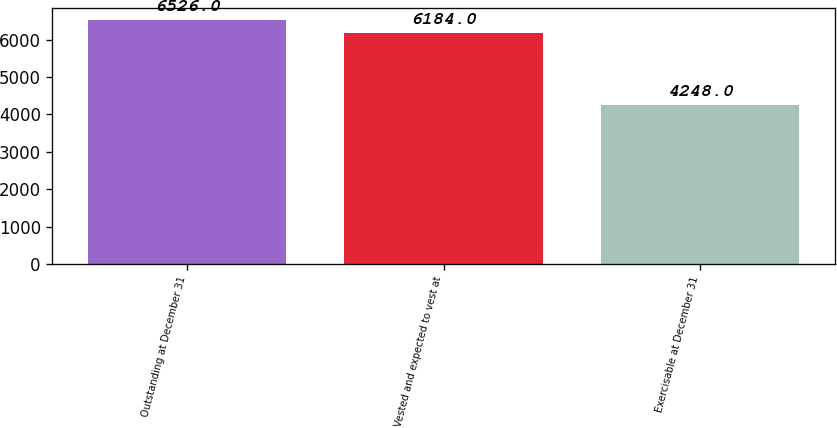Convert chart to OTSL. <chart><loc_0><loc_0><loc_500><loc_500><bar_chart><fcel>Outstanding at December 31<fcel>Vested and expected to vest at<fcel>Exercisable at December 31<nl><fcel>6526<fcel>6184<fcel>4248<nl></chart> 